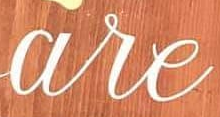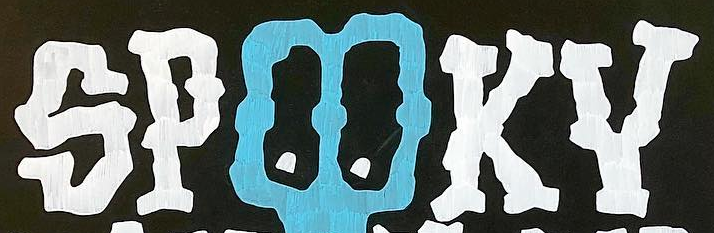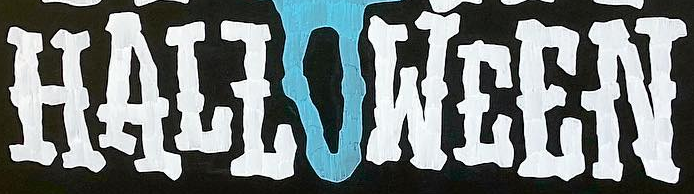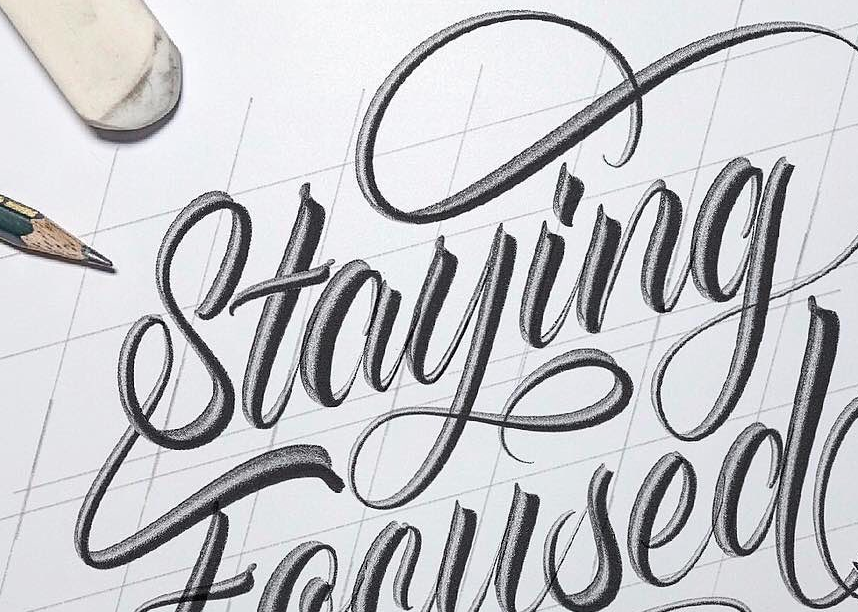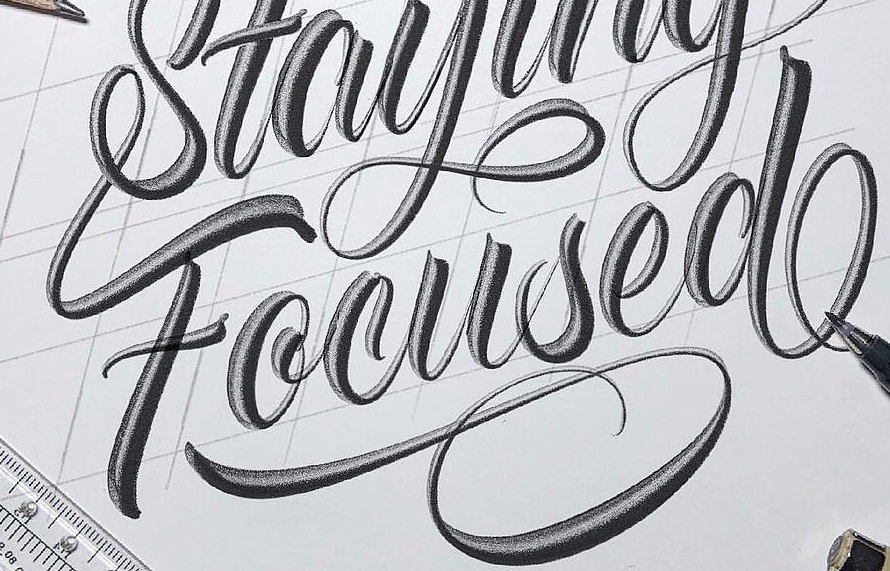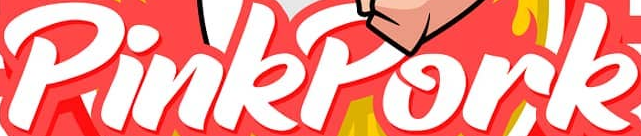What words can you see in these images in sequence, separated by a semicolon? are; SPOOKY; HALLOWEEN; Staying; Focused; PinkPork 